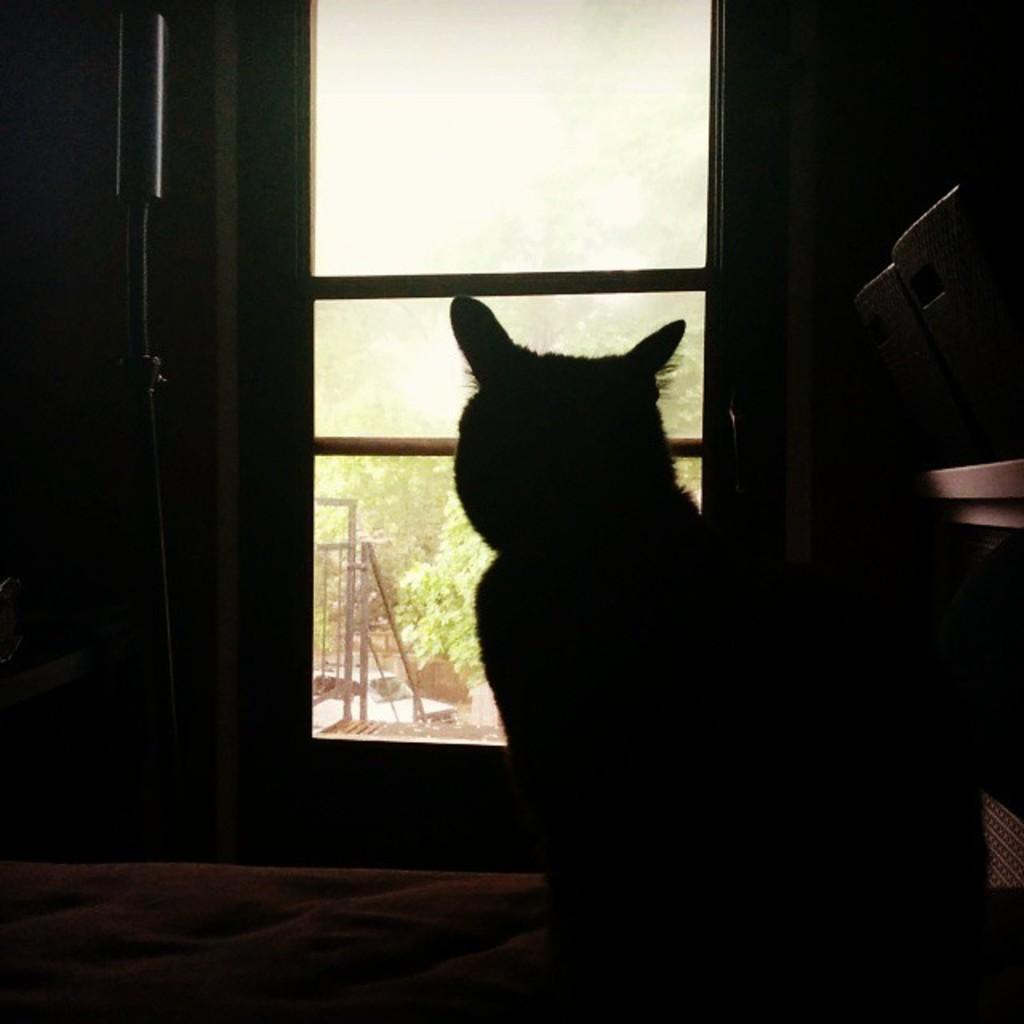Could you give a brief overview of what you see in this image? In this image we can see the bed, cat and also the window and through the window we can see the railing, trees and also the sky. We can also see some other objects. 